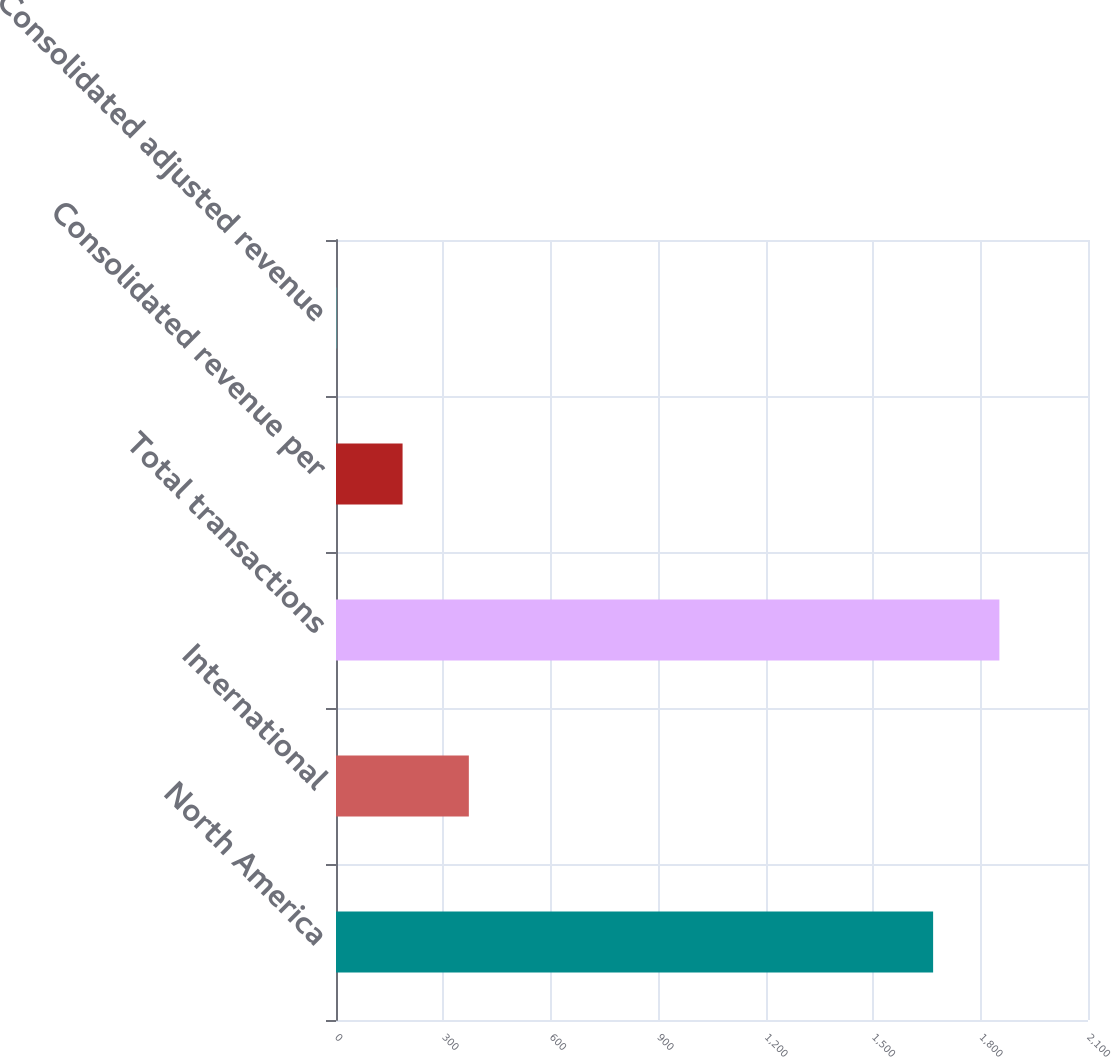Convert chart to OTSL. <chart><loc_0><loc_0><loc_500><loc_500><bar_chart><fcel>North America<fcel>International<fcel>Total transactions<fcel>Consolidated revenue per<fcel>Consolidated adjusted revenue<nl><fcel>1667.5<fcel>370.96<fcel>1852.55<fcel>185.91<fcel>0.86<nl></chart> 